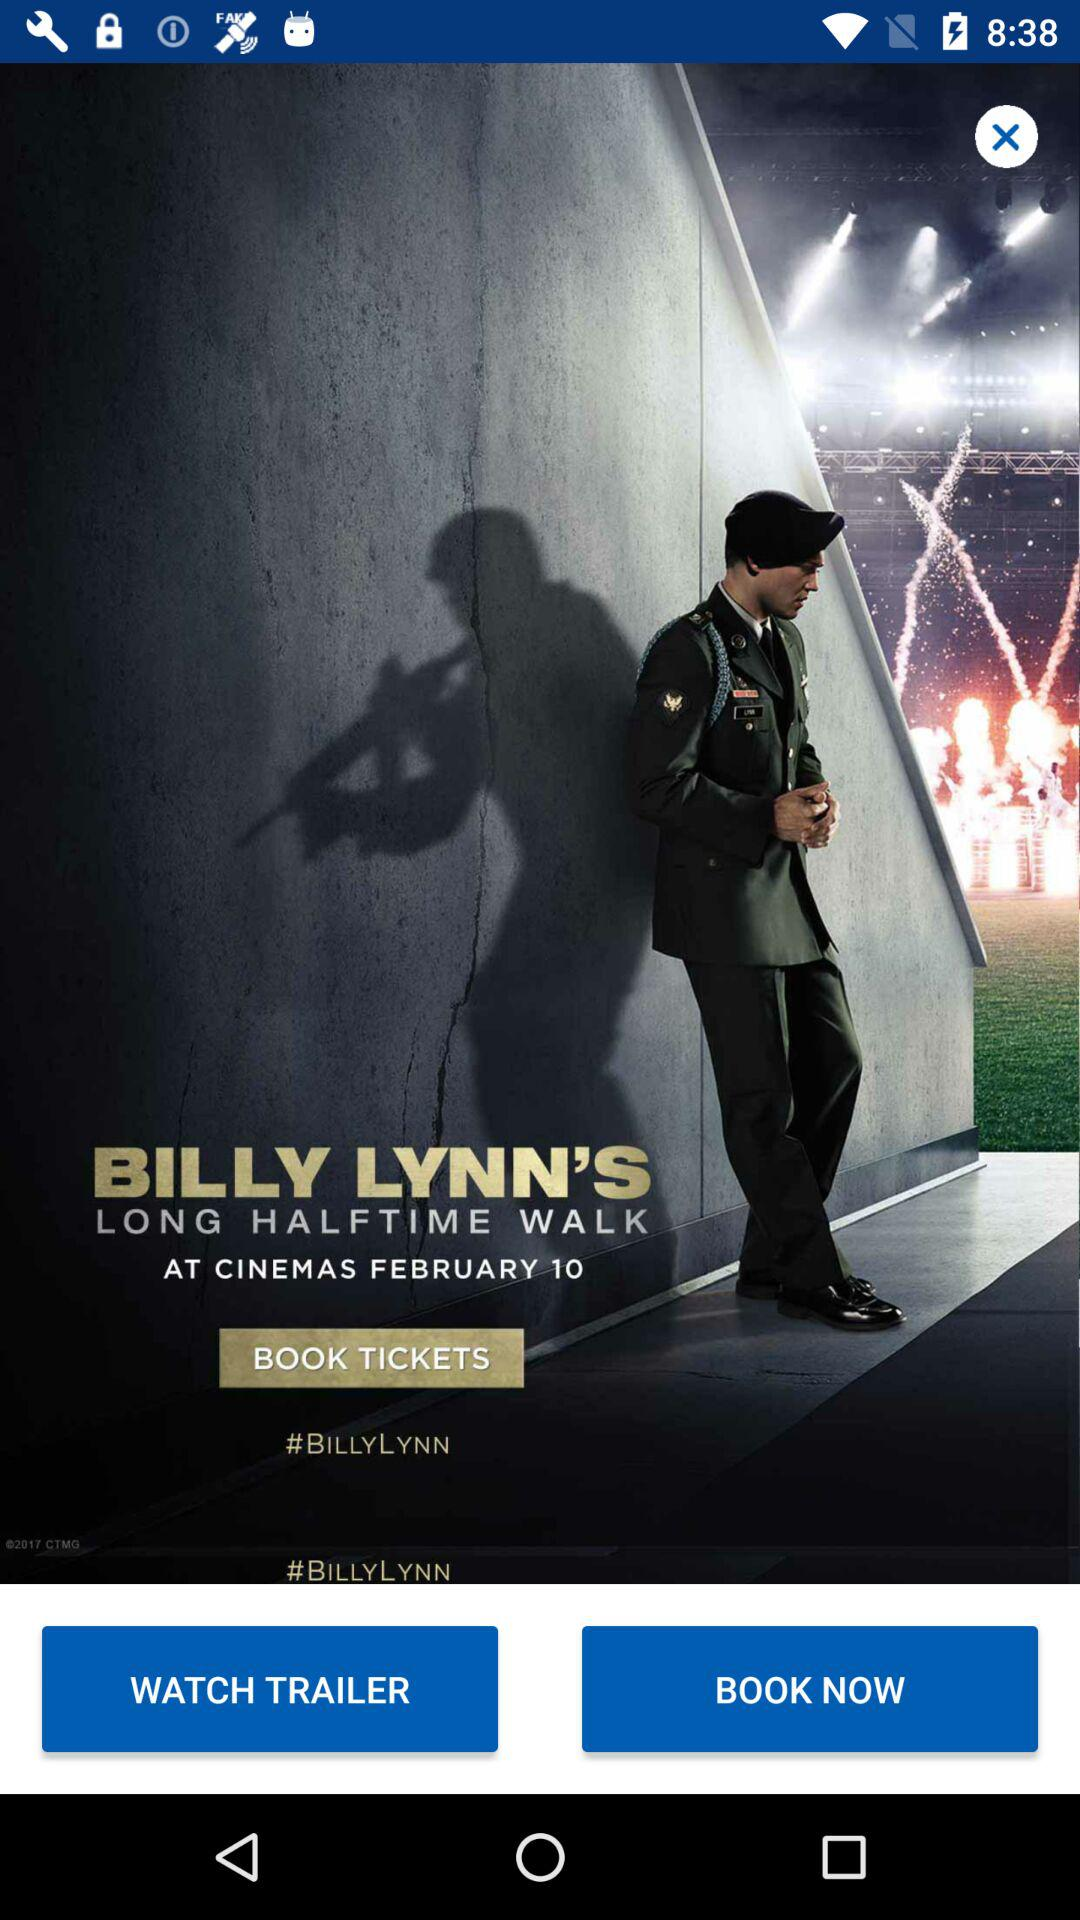On what date will the movie Billy Lynn's be released in cinemas? The date is February 10. 